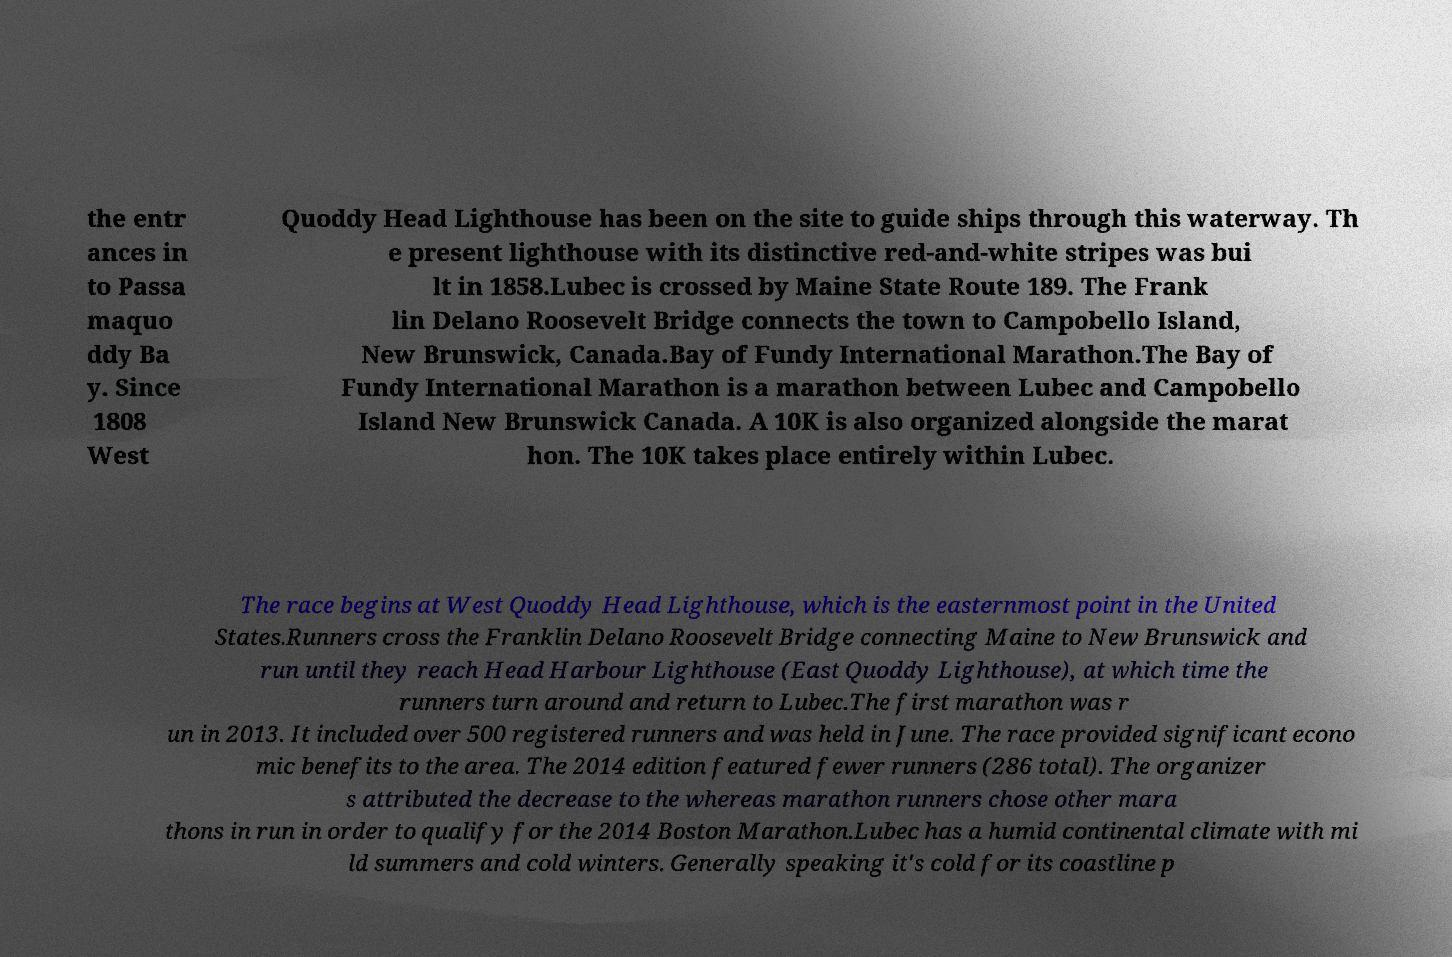What messages or text are displayed in this image? I need them in a readable, typed format. the entr ances in to Passa maquo ddy Ba y. Since 1808 West Quoddy Head Lighthouse has been on the site to guide ships through this waterway. Th e present lighthouse with its distinctive red-and-white stripes was bui lt in 1858.Lubec is crossed by Maine State Route 189. The Frank lin Delano Roosevelt Bridge connects the town to Campobello Island, New Brunswick, Canada.Bay of Fundy International Marathon.The Bay of Fundy International Marathon is a marathon between Lubec and Campobello Island New Brunswick Canada. A 10K is also organized alongside the marat hon. The 10K takes place entirely within Lubec. The race begins at West Quoddy Head Lighthouse, which is the easternmost point in the United States.Runners cross the Franklin Delano Roosevelt Bridge connecting Maine to New Brunswick and run until they reach Head Harbour Lighthouse (East Quoddy Lighthouse), at which time the runners turn around and return to Lubec.The first marathon was r un in 2013. It included over 500 registered runners and was held in June. The race provided significant econo mic benefits to the area. The 2014 edition featured fewer runners (286 total). The organizer s attributed the decrease to the whereas marathon runners chose other mara thons in run in order to qualify for the 2014 Boston Marathon.Lubec has a humid continental climate with mi ld summers and cold winters. Generally speaking it's cold for its coastline p 